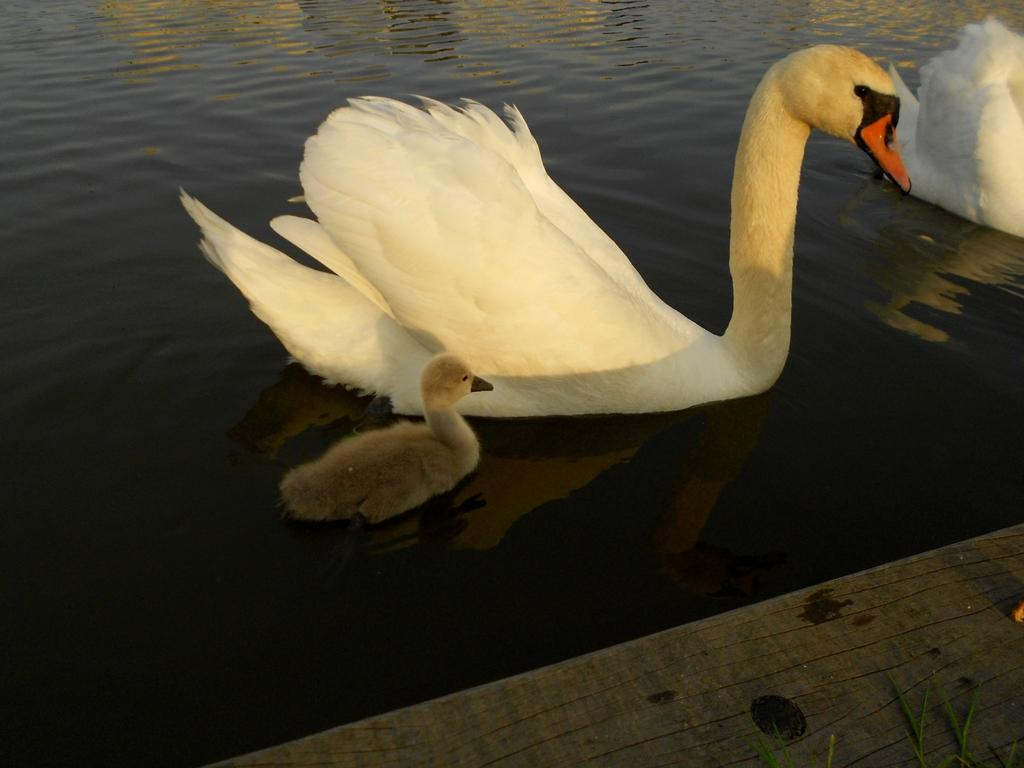What is the main element in the image? There is water in the image. What animals can be seen in the water? There are swans in the water. What else is visible in the image besides the water and swans? The ground is visible in the image. Can you describe the objects at the bottom of the image? There are objects at the bottom of the image, but their specific details are not mentioned in the provided facts. What type of need can be seen in the image? There is no mention of a need in the image, so it cannot be determined from the provided facts. 